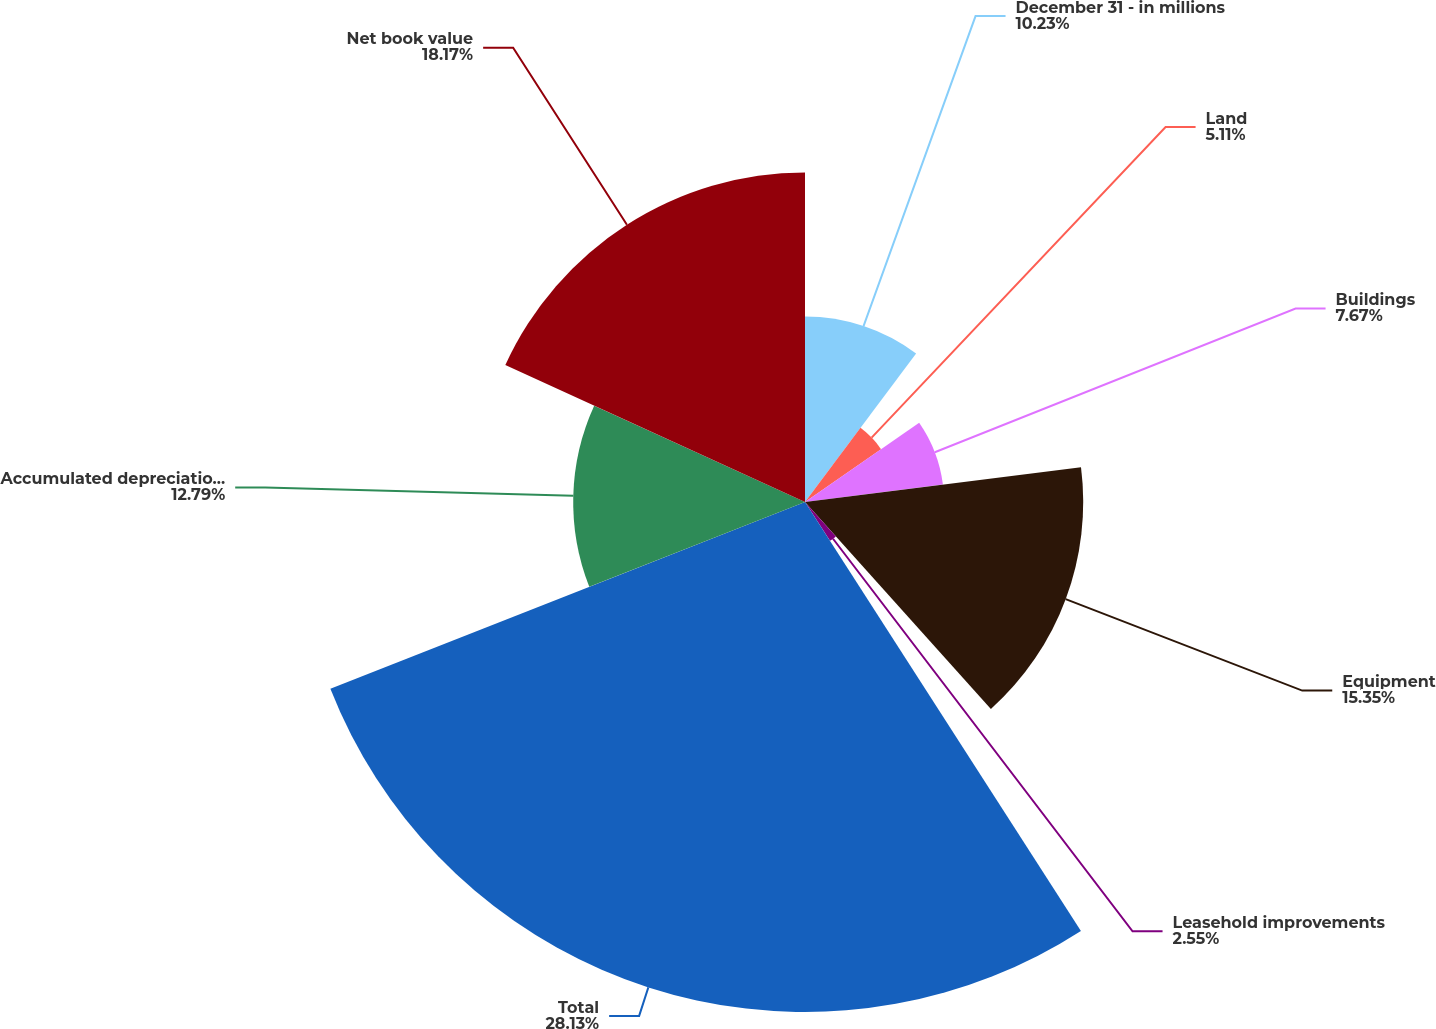Convert chart to OTSL. <chart><loc_0><loc_0><loc_500><loc_500><pie_chart><fcel>December 31 - in millions<fcel>Land<fcel>Buildings<fcel>Equipment<fcel>Leasehold improvements<fcel>Total<fcel>Accumulated depreciation and<fcel>Net book value<nl><fcel>10.23%<fcel>5.11%<fcel>7.67%<fcel>15.35%<fcel>2.55%<fcel>28.14%<fcel>12.79%<fcel>18.18%<nl></chart> 